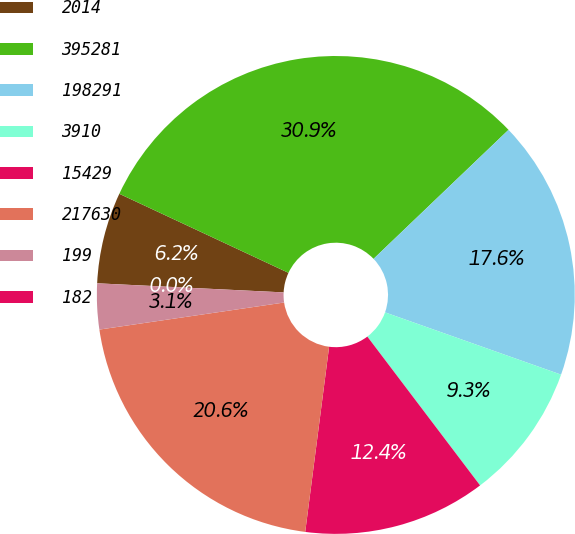Convert chart to OTSL. <chart><loc_0><loc_0><loc_500><loc_500><pie_chart><fcel>2014<fcel>395281<fcel>198291<fcel>3910<fcel>15429<fcel>217630<fcel>199<fcel>182<nl><fcel>6.18%<fcel>30.9%<fcel>17.55%<fcel>9.27%<fcel>12.36%<fcel>20.64%<fcel>3.09%<fcel>0.0%<nl></chart> 